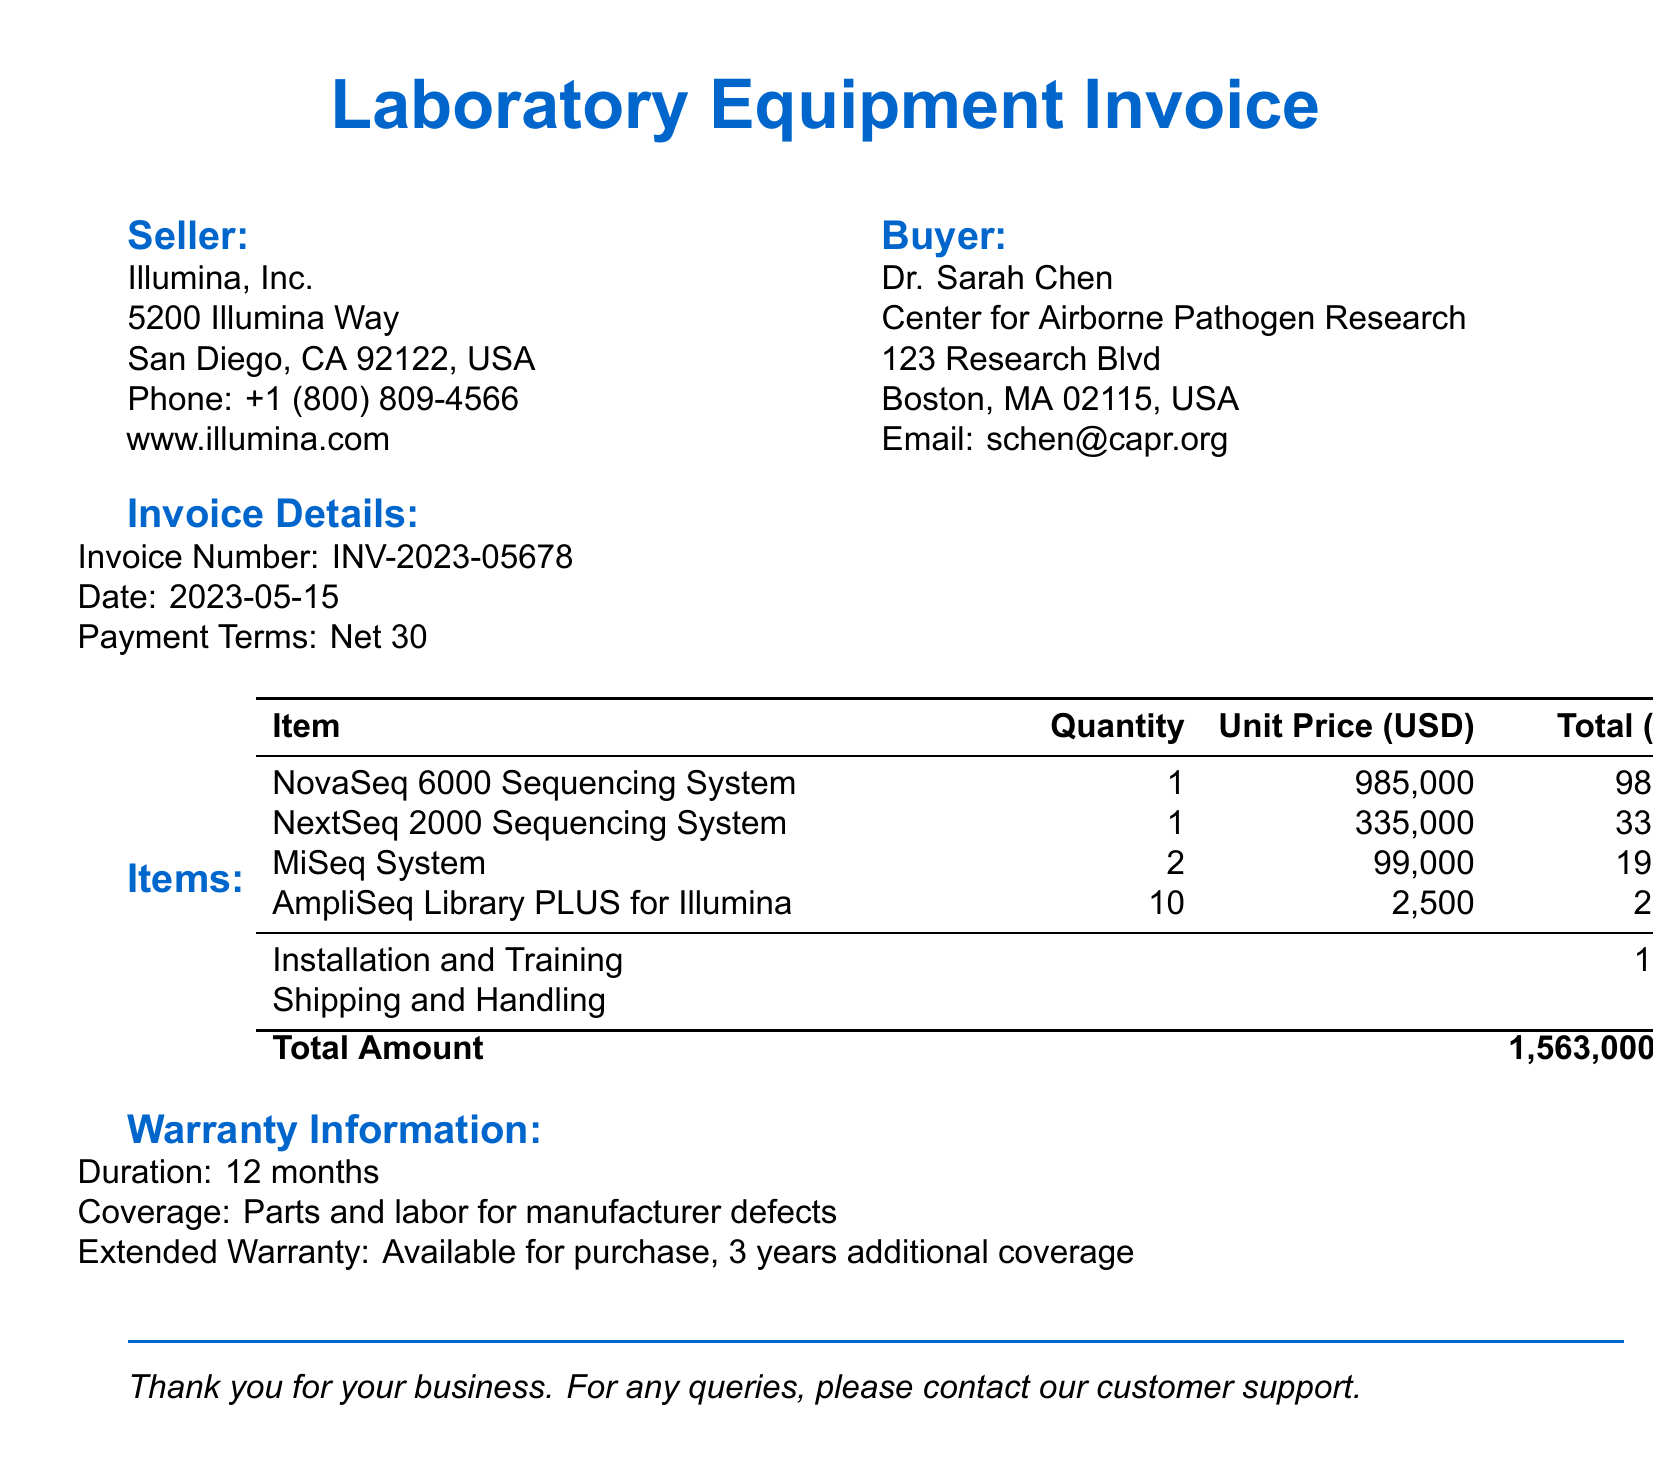What is the invoice number? The invoice number is listed under Invoice Details, which is INV-2023-05678.
Answer: INV-2023-05678 Who is the seller? The seller's name and details are provided in the document, which is Illumina, Inc.
Answer: Illumina, Inc What is the total amount of the invoice? The total amount is specified at the end of the itemized costs which is 1,563,000 USD.
Answer: 1,563,000 USD How many units of the MiSeq System were purchased? The quantity of the MiSeq System is indicated in the items list as 2.
Answer: 2 What is the duration of the warranty? The warranty details state that the duration is 12 months.
Answer: 12 months What is included in the coverage of the warranty? The coverage information states that it includes parts and labor for manufacturer defects.
Answer: Parts and labor for manufacturer defects What is the quantity and unit price of the NovaSeq 6000 Sequencing System? The quantity is 1 and the unit price is listed as 985,000 USD.
Answer: 1; 985,000 USD What types of services are included in the additional charges? The additional charges listed installation and training, and shipping and handling.
Answer: Installation and Training; Shipping and Handling Is an extended warranty available for purchase? The document explicitly states that an extended warranty is available for purchase, providing additional coverage.
Answer: Yes 